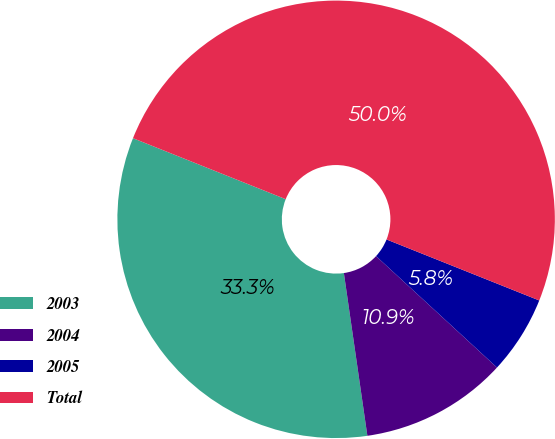Convert chart to OTSL. <chart><loc_0><loc_0><loc_500><loc_500><pie_chart><fcel>2003<fcel>2004<fcel>2005<fcel>Total<nl><fcel>33.33%<fcel>10.87%<fcel>5.8%<fcel>50.0%<nl></chart> 